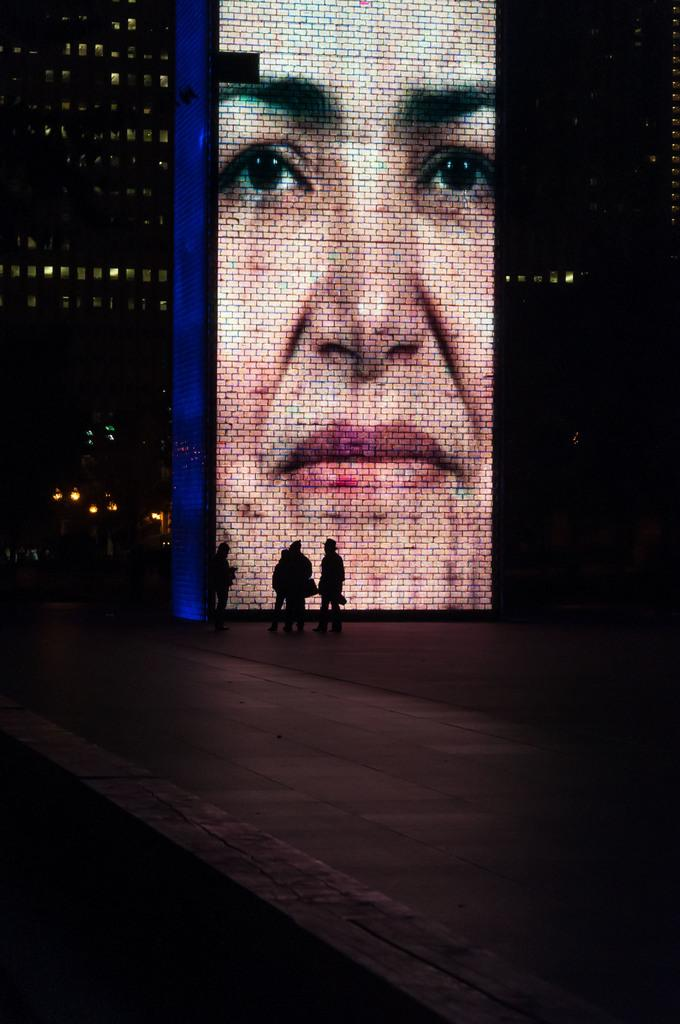What are the people in the image doing? The people in the image are standing in front of a screen. What is displayed on the screen? The screen displays a person's face. What can be seen in the background of the image? There is a building with lights in the background. What color is the shirt worn by the person on the screen? There is no information about the shirt worn by the person on the screen, as the provided facts only mention that the screen displays a person's face. What story is being told by the people in the image? There is no information about a story being told by the people in the image, as the provided facts only mention their actions and the presence of a screen displaying a person's face. 